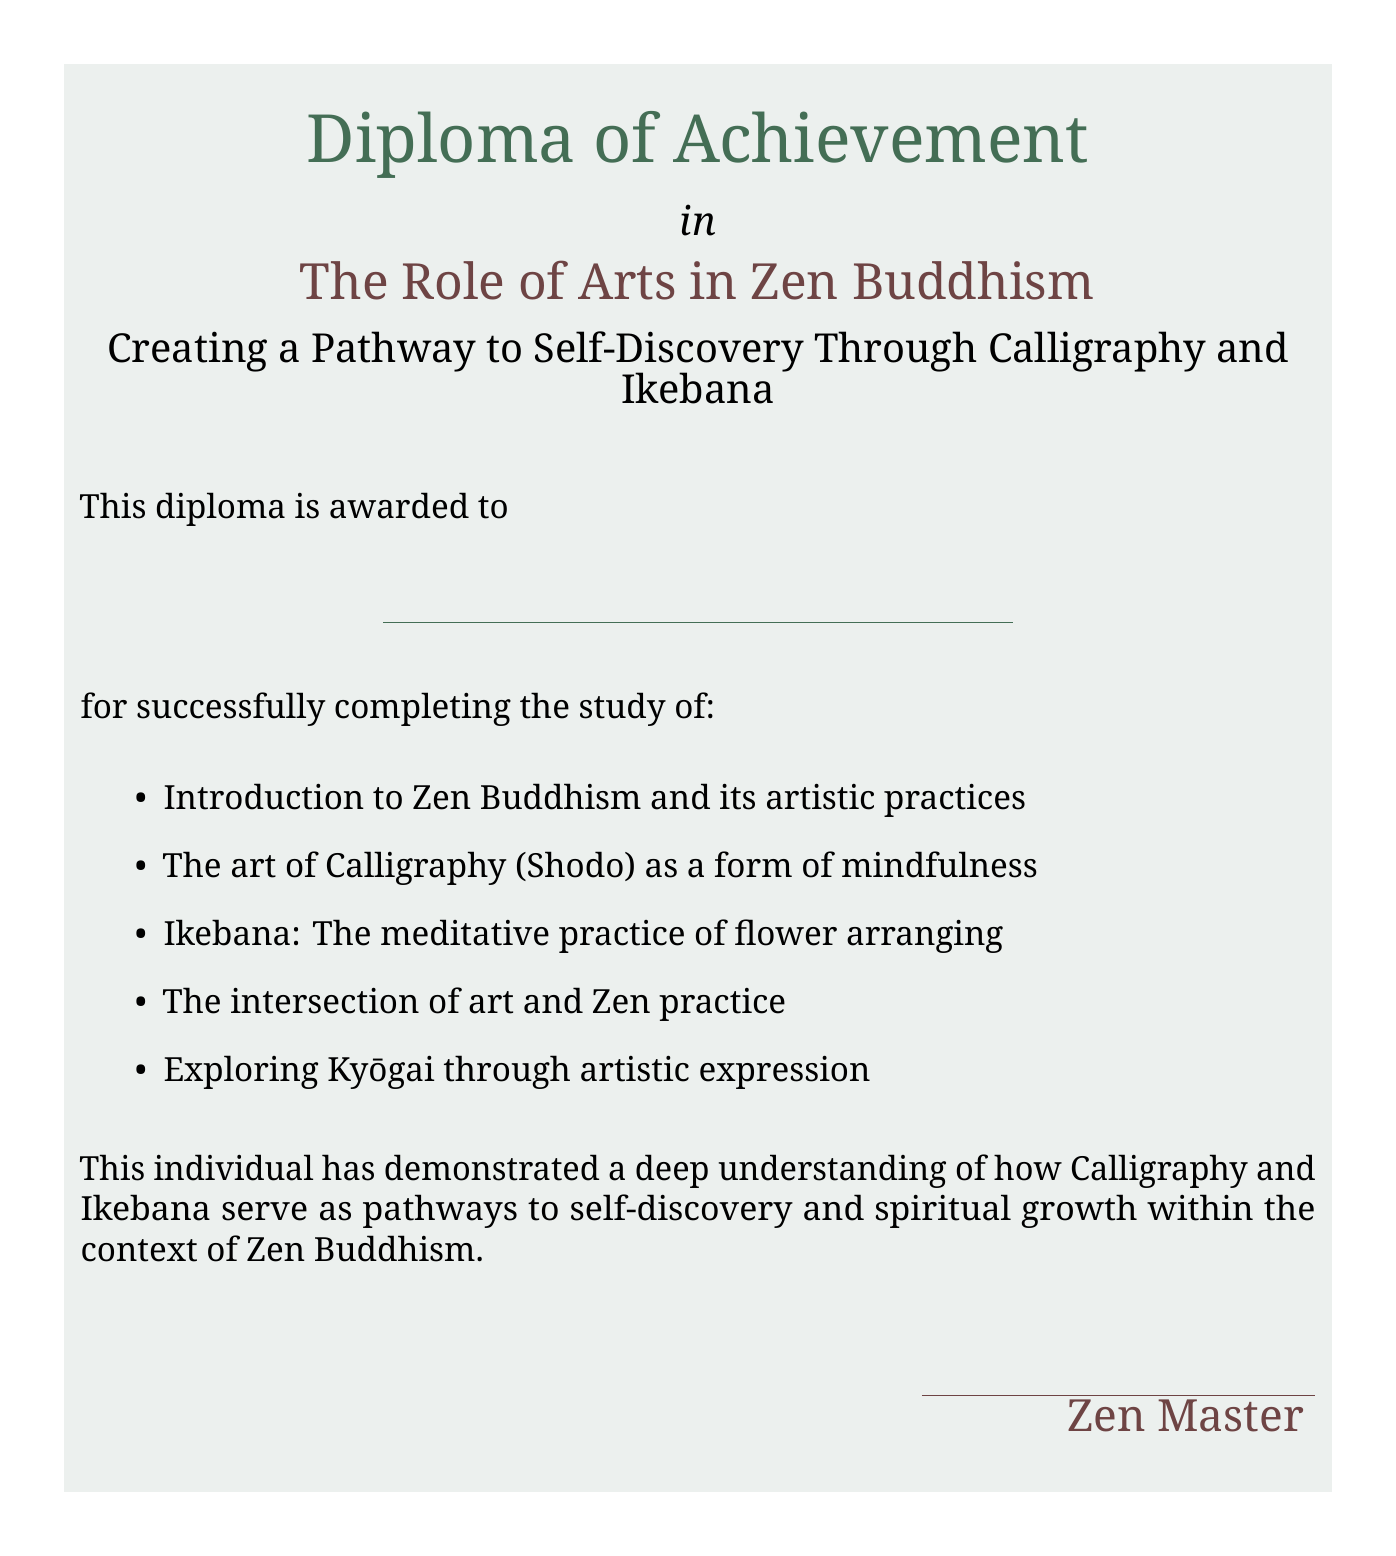What is the title of the diploma? The title of the diploma is prominently displayed in the center of the document.
Answer: The Role of Arts in Zen Buddhism Who is this diploma awarded to? The awardee's name is represented by a blank line in the document, indicating a customizable space for the individual's name.
Answer: \underline{\hspace{8cm}} What are the two main artistic practices discussed? The document lists specific arts in the context of Zen Buddhism.
Answer: Calligraphy and Ikebana How many areas of study are listed in the document? The document enumerates the subjects covered in the study.
Answer: Five What is the significance of Calligraphy and Ikebana according to the diploma? The document specifies what these arts provide in the context of Zen Buddhism and self-discovery.
Answer: Pathways to self-discovery Who signs the diploma? The document indicates a role that would typically sign such an honor.
Answer: Zen Master What is the color of the calligraphy font used in the diploma? The color choice for the calligraphy font is specifically mentioned in the document.
Answer: Zen brown What is the size of the font used for the diploma title? The title's font size is explicitly stated in the document.
Answer: 24 What does the diploma recognize about the individual's understanding? The document specifies what knowledge the individual has demonstrated.
Answer: Deep understanding 